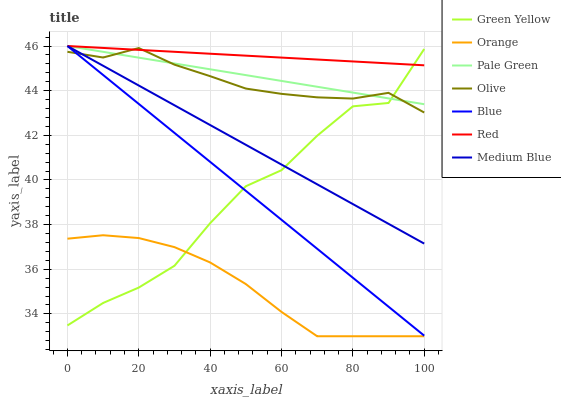Does Medium Blue have the minimum area under the curve?
Answer yes or no. No. Does Medium Blue have the maximum area under the curve?
Answer yes or no. No. Is Medium Blue the smoothest?
Answer yes or no. No. Is Medium Blue the roughest?
Answer yes or no. No. Does Medium Blue have the lowest value?
Answer yes or no. No. Does Olive have the highest value?
Answer yes or no. No. Is Orange less than Pale Green?
Answer yes or no. Yes. Is Red greater than Orange?
Answer yes or no. Yes. Does Orange intersect Pale Green?
Answer yes or no. No. 